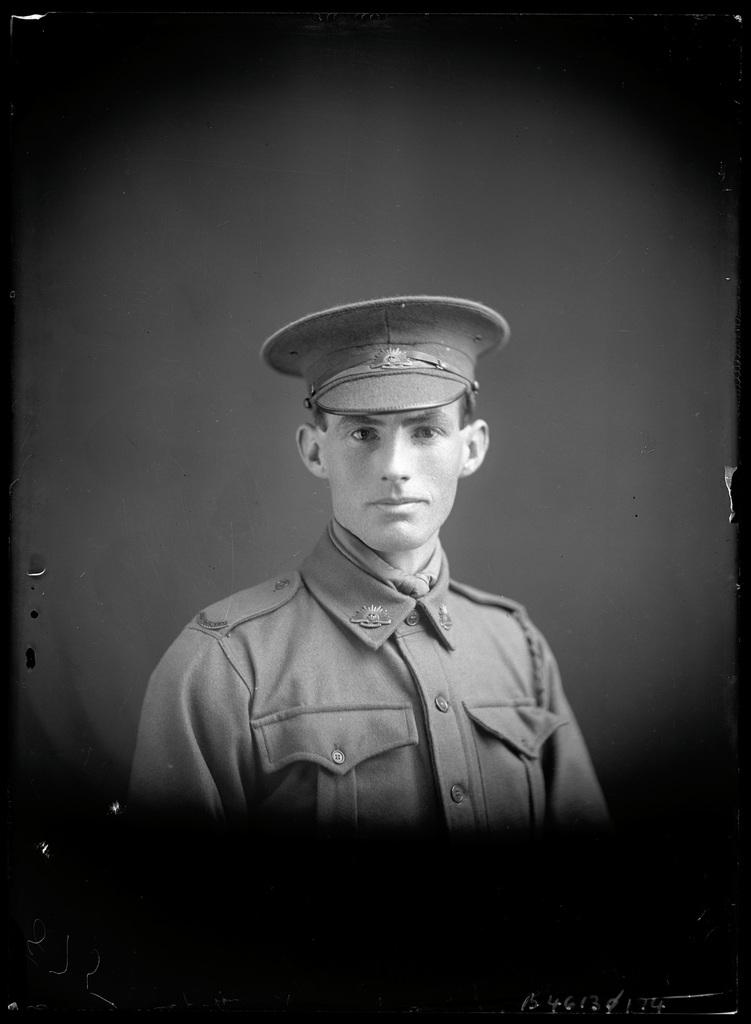What is the main subject of the image? The main subject of the image is a man. What is the man wearing on his head? The man is wearing a cap. What is the man's facial expression in the image? The man is smiling. What can be observed about the background of the image? The background of the image is dark. Is there any steam coming from the man's cap in the image? No, there is no steam present in the image. What stage of development is the man in the image? The image does not provide any information about the man's stage of development. 